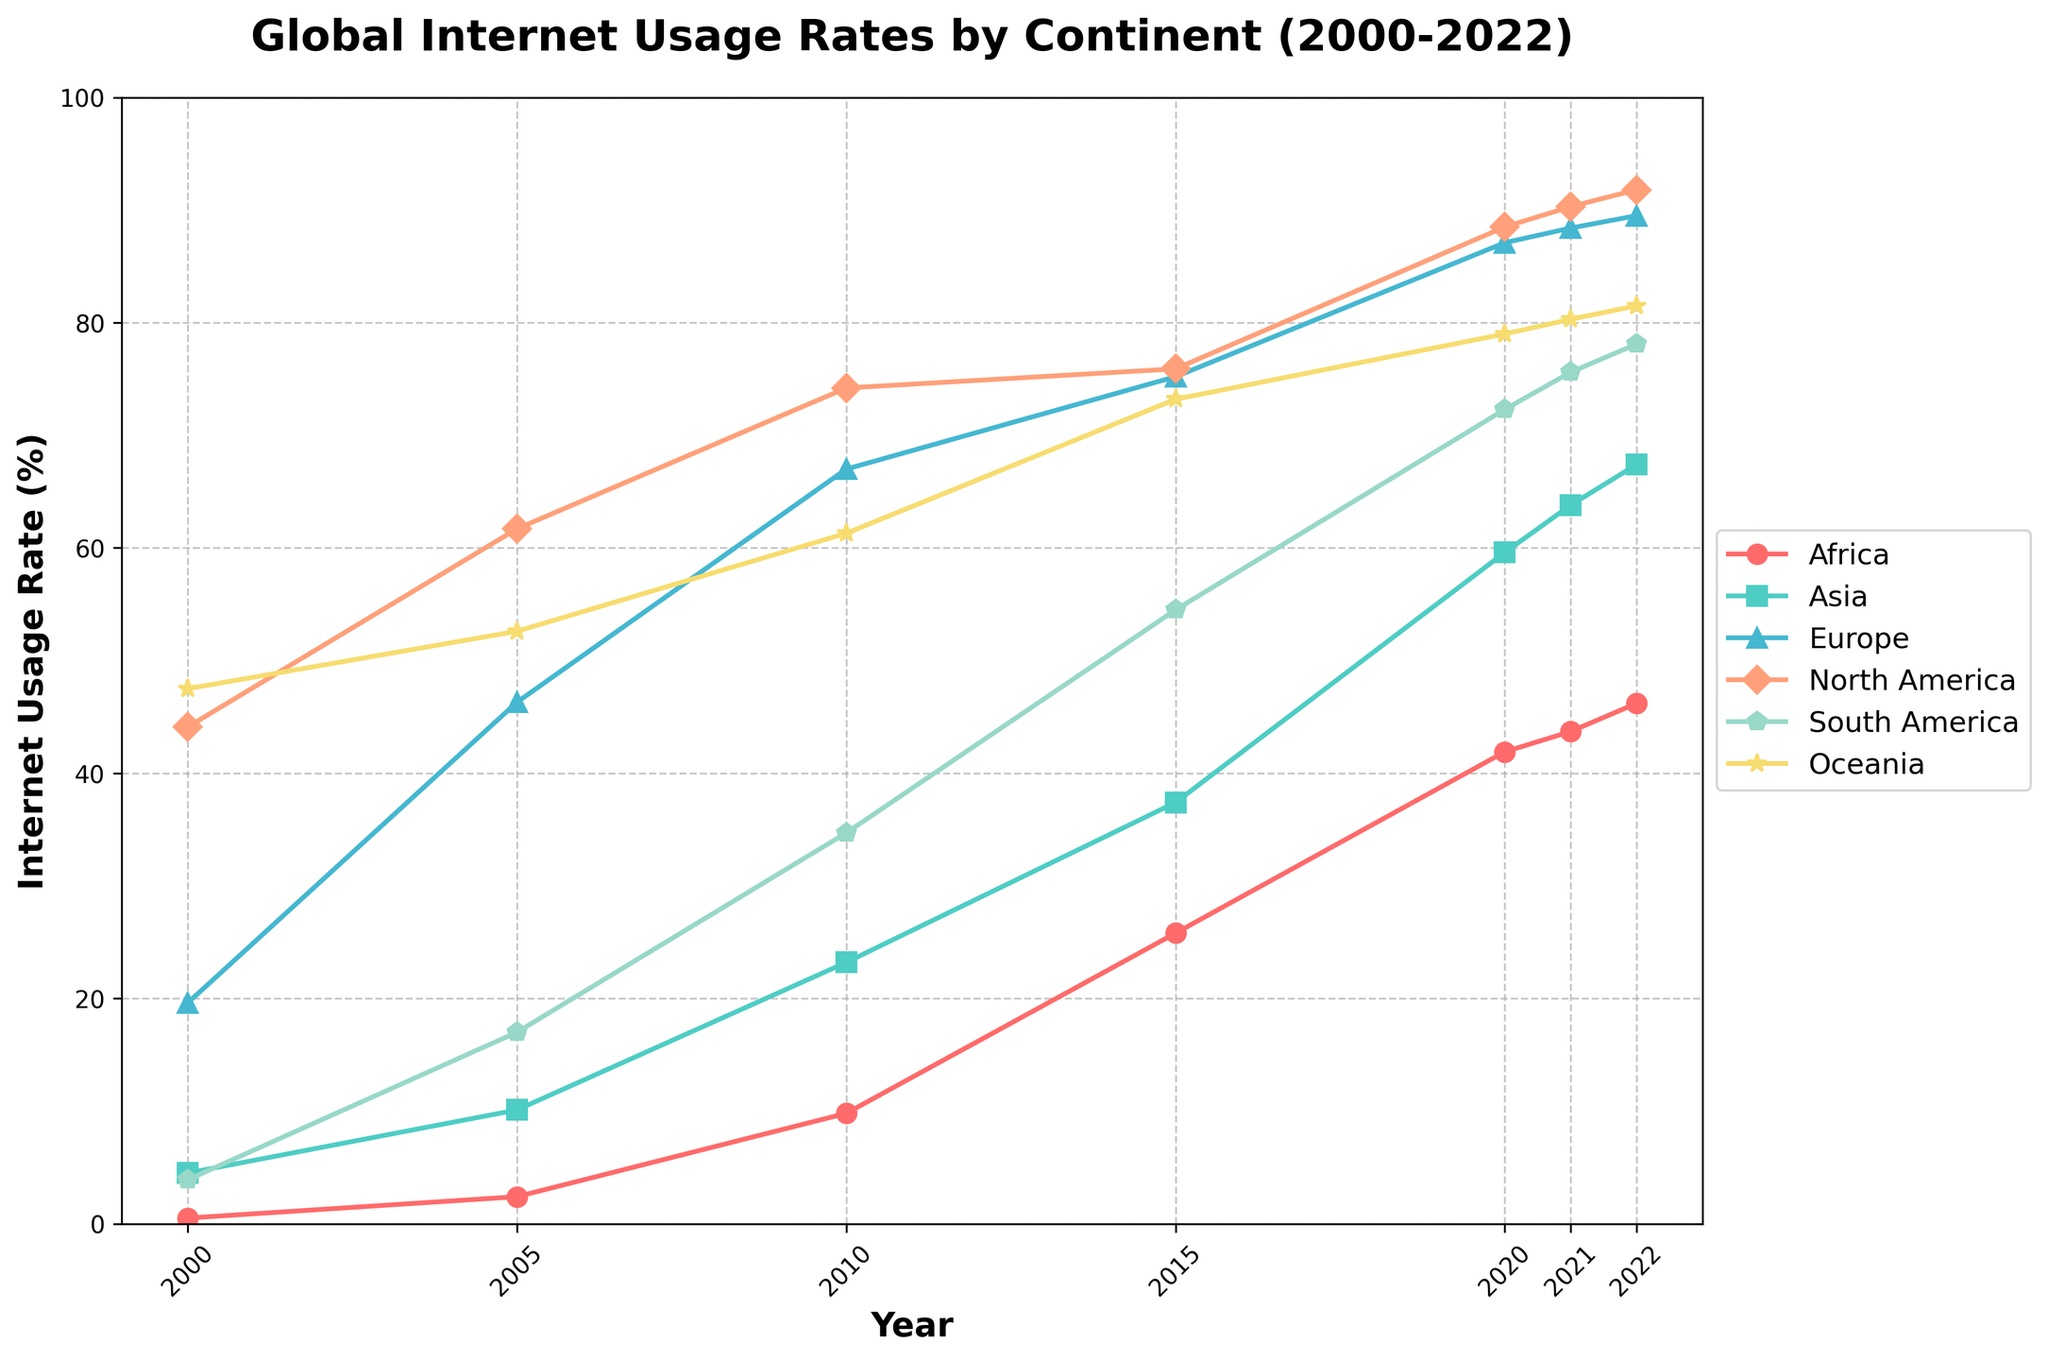Which continent had the highest internet usage rate in 2022? Look at the data points for the year 2022 on the figure. Identify which line reaches the closest to 100% on the y-axis. For 2022, North America has the highest internet usage rate.
Answer: North America How did the internet usage rate in Africa change from 2005 to 2020? Observe the points corresponding to Africa in the years 2005 and 2020. Subtract the 2005 rate from the 2020 rate: 41.9% - 2.4%
Answer: 39.5% Between 2010 and 2022, which continent showed the smallest increase in internet usage rate? Calculate the difference between 2010 and 2022 for each continent and compare. Europe increased from 67.0% to 89.5%, a change of 22.5%, which is the smallest among the continents.
Answer: Europe Which continents showed an increasing trend in internet usage from 2000 to 2022? Check the trend for each continent from 2000 to 2022. All continents showed a consistently increasing trend.
Answer: All continents In which year did Asia surpass 50% internet usage rate? Identify the data points for Asia over the years. The usage rate crosses 50% between 2015 and 2020, specifically in 2020.
Answer: 2020 By how much did the internet usage rate in South America increase from 2015 to 2021? Find the data points for South America in 2015 and 2021 and calculate the difference: 75.6% - 54.5% = 21.1%.
Answer: 21.1% Which continent had the lowest internet usage rate in 2000? Look at the data points for the year 2000 and determine the lowest value. Africa had the lowest internet usage rate at 0.5%.
Answer: Africa Did Oceania maintain a higher internet usage rate than Asia throughout the years 2000 to 2022? Compare the data points for Oceania and Asia for each year. Oceania consistently has higher rates than Asia.
Answer: Yes What is the approximate average internet usage rate for Europe from 2000 to 2022? Sum up the values for Europe for all years and divide by the number of data points. Calculation: (19.6 + 46.3 + 67.0 + 75.2 + 87.1 + 88.4 + 89.5) / 7 ≈ 67.6
Answer: 67.6% Which continent showed the most rapid growth in internet usage rate between 2000 and 2005? Calculate the difference for each continent between 2000 and 2005 and find the highest change. Africa increased from 0.5% to 2.4%, which is a relative increase of 1.9, the largest rate of growth.
Answer: Africa 